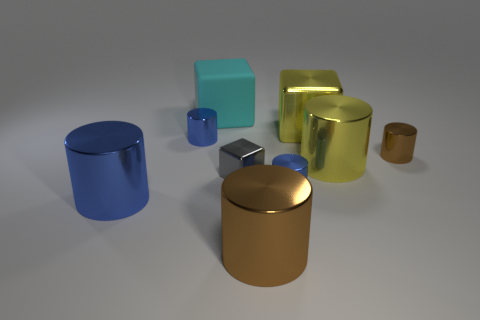What material is the cyan block behind the big yellow metallic thing right of the yellow cube made of?
Your answer should be compact. Rubber. Is the shape of the big yellow thing behind the yellow shiny cylinder the same as  the matte object?
Offer a very short reply. Yes. What is the color of the other block that is made of the same material as the tiny cube?
Offer a terse response. Yellow. What is the block that is to the right of the small metal cube made of?
Your response must be concise. Metal. Do the small gray metallic object and the cyan rubber object to the left of the big brown thing have the same shape?
Give a very brief answer. Yes. There is a tiny cylinder that is both to the right of the cyan thing and behind the tiny block; what material is it?
Your answer should be compact. Metal. What color is the metallic block that is the same size as the cyan matte cube?
Ensure brevity in your answer.  Yellow. Is the material of the gray thing the same as the large thing on the left side of the large matte cube?
Give a very brief answer. Yes. How many other things are there of the same size as the cyan cube?
Offer a terse response. 4. Is there a big metal object that is in front of the small blue cylinder that is to the left of the brown cylinder that is left of the large yellow cylinder?
Give a very brief answer. Yes. 